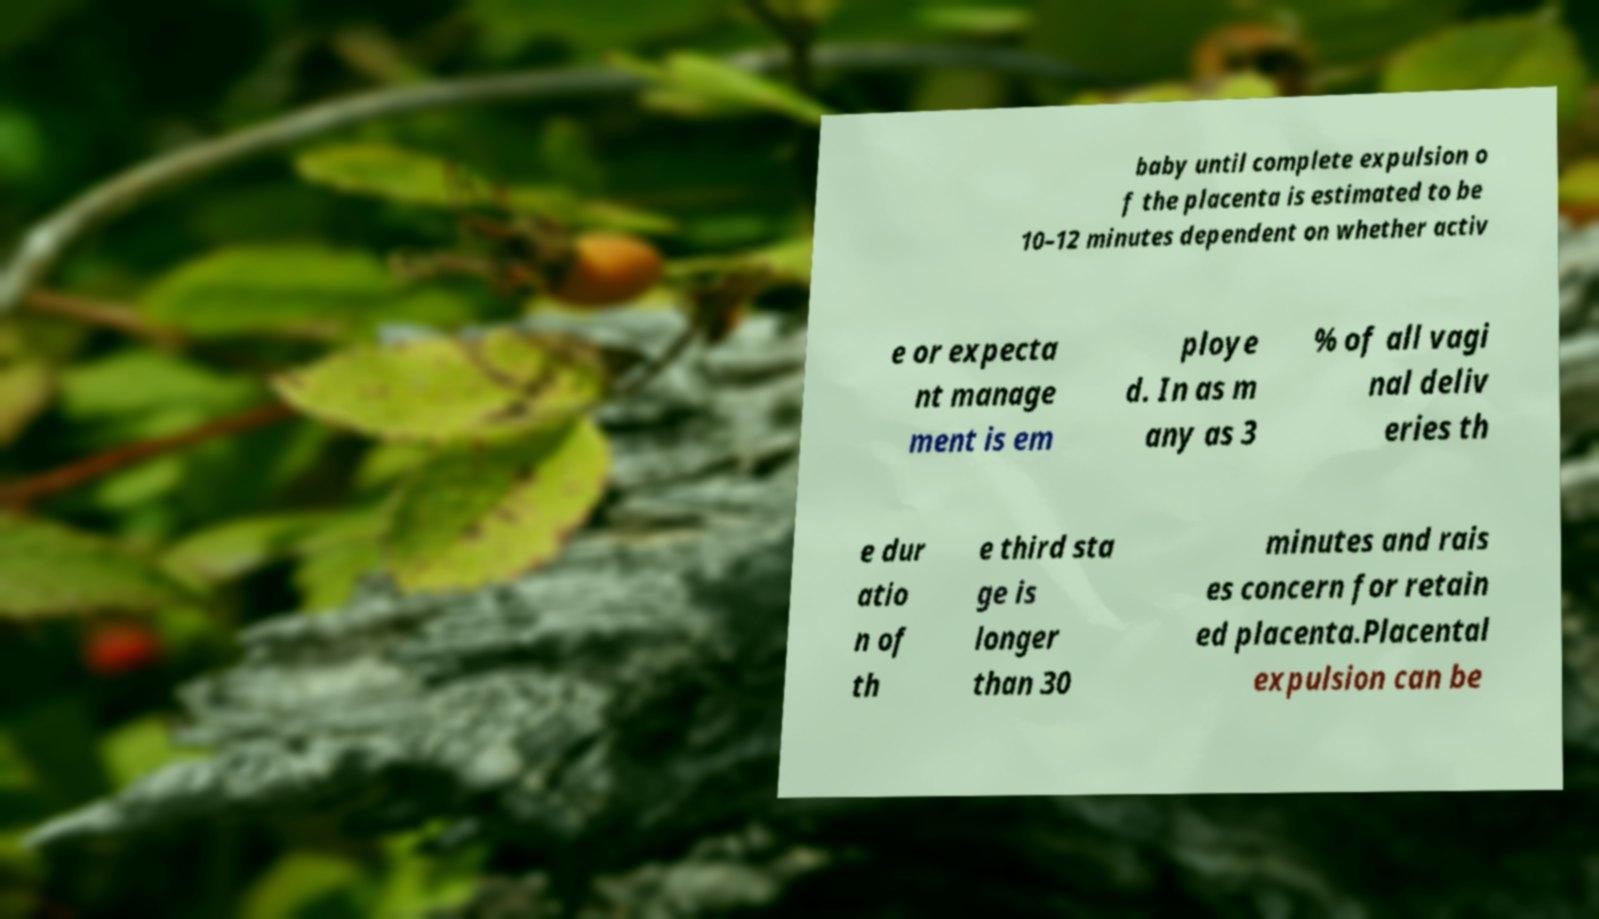Can you accurately transcribe the text from the provided image for me? baby until complete expulsion o f the placenta is estimated to be 10–12 minutes dependent on whether activ e or expecta nt manage ment is em ploye d. In as m any as 3 % of all vagi nal deliv eries th e dur atio n of th e third sta ge is longer than 30 minutes and rais es concern for retain ed placenta.Placental expulsion can be 